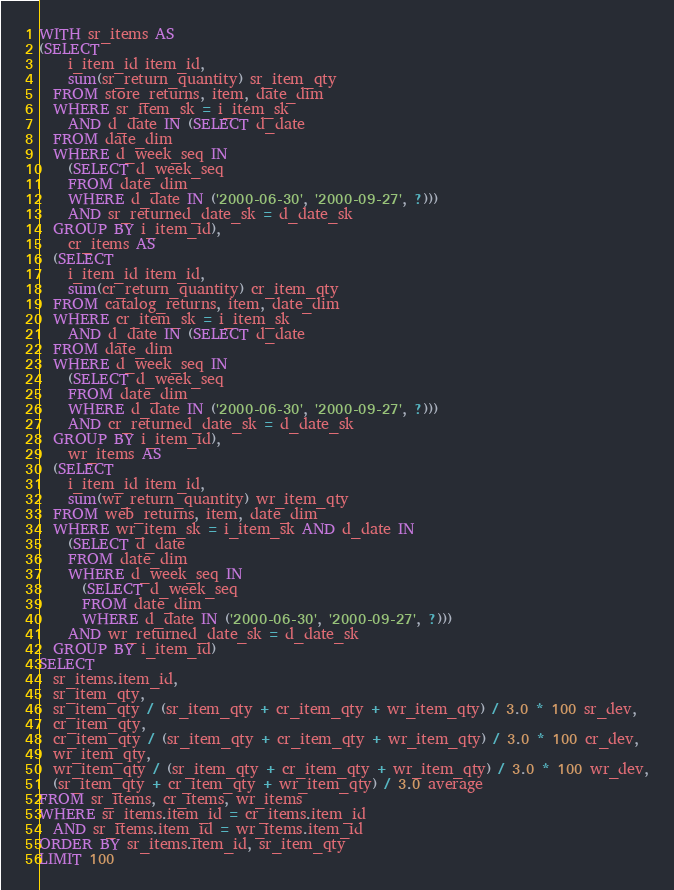Convert code to text. <code><loc_0><loc_0><loc_500><loc_500><_SQL_>WITH sr_items AS
(SELECT
    i_item_id item_id,
    sum(sr_return_quantity) sr_item_qty
  FROM store_returns, item, date_dim
  WHERE sr_item_sk = i_item_sk
    AND d_date IN (SELECT d_date
  FROM date_dim
  WHERE d_week_seq IN
    (SELECT d_week_seq
    FROM date_dim
    WHERE d_date IN ('2000-06-30', '2000-09-27', ?)))
    AND sr_returned_date_sk = d_date_sk
  GROUP BY i_item_id),
    cr_items AS
  (SELECT
    i_item_id item_id,
    sum(cr_return_quantity) cr_item_qty
  FROM catalog_returns, item, date_dim
  WHERE cr_item_sk = i_item_sk
    AND d_date IN (SELECT d_date
  FROM date_dim
  WHERE d_week_seq IN
    (SELECT d_week_seq
    FROM date_dim
    WHERE d_date IN ('2000-06-30', '2000-09-27', ?)))
    AND cr_returned_date_sk = d_date_sk
  GROUP BY i_item_id),
    wr_items AS
  (SELECT
    i_item_id item_id,
    sum(wr_return_quantity) wr_item_qty
  FROM web_returns, item, date_dim
  WHERE wr_item_sk = i_item_sk AND d_date IN
    (SELECT d_date
    FROM date_dim
    WHERE d_week_seq IN
      (SELECT d_week_seq
      FROM date_dim
      WHERE d_date IN ('2000-06-30', '2000-09-27', ?)))
    AND wr_returned_date_sk = d_date_sk
  GROUP BY i_item_id)
SELECT
  sr_items.item_id,
  sr_item_qty,
  sr_item_qty / (sr_item_qty + cr_item_qty + wr_item_qty) / 3.0 * 100 sr_dev,
  cr_item_qty,
  cr_item_qty / (sr_item_qty + cr_item_qty + wr_item_qty) / 3.0 * 100 cr_dev,
  wr_item_qty,
  wr_item_qty / (sr_item_qty + cr_item_qty + wr_item_qty) / 3.0 * 100 wr_dev,
  (sr_item_qty + cr_item_qty + wr_item_qty) / 3.0 average
FROM sr_items, cr_items, wr_items
WHERE sr_items.item_id = cr_items.item_id
  AND sr_items.item_id = wr_items.item_id
ORDER BY sr_items.item_id, sr_item_qty
LIMIT 100
</code> 